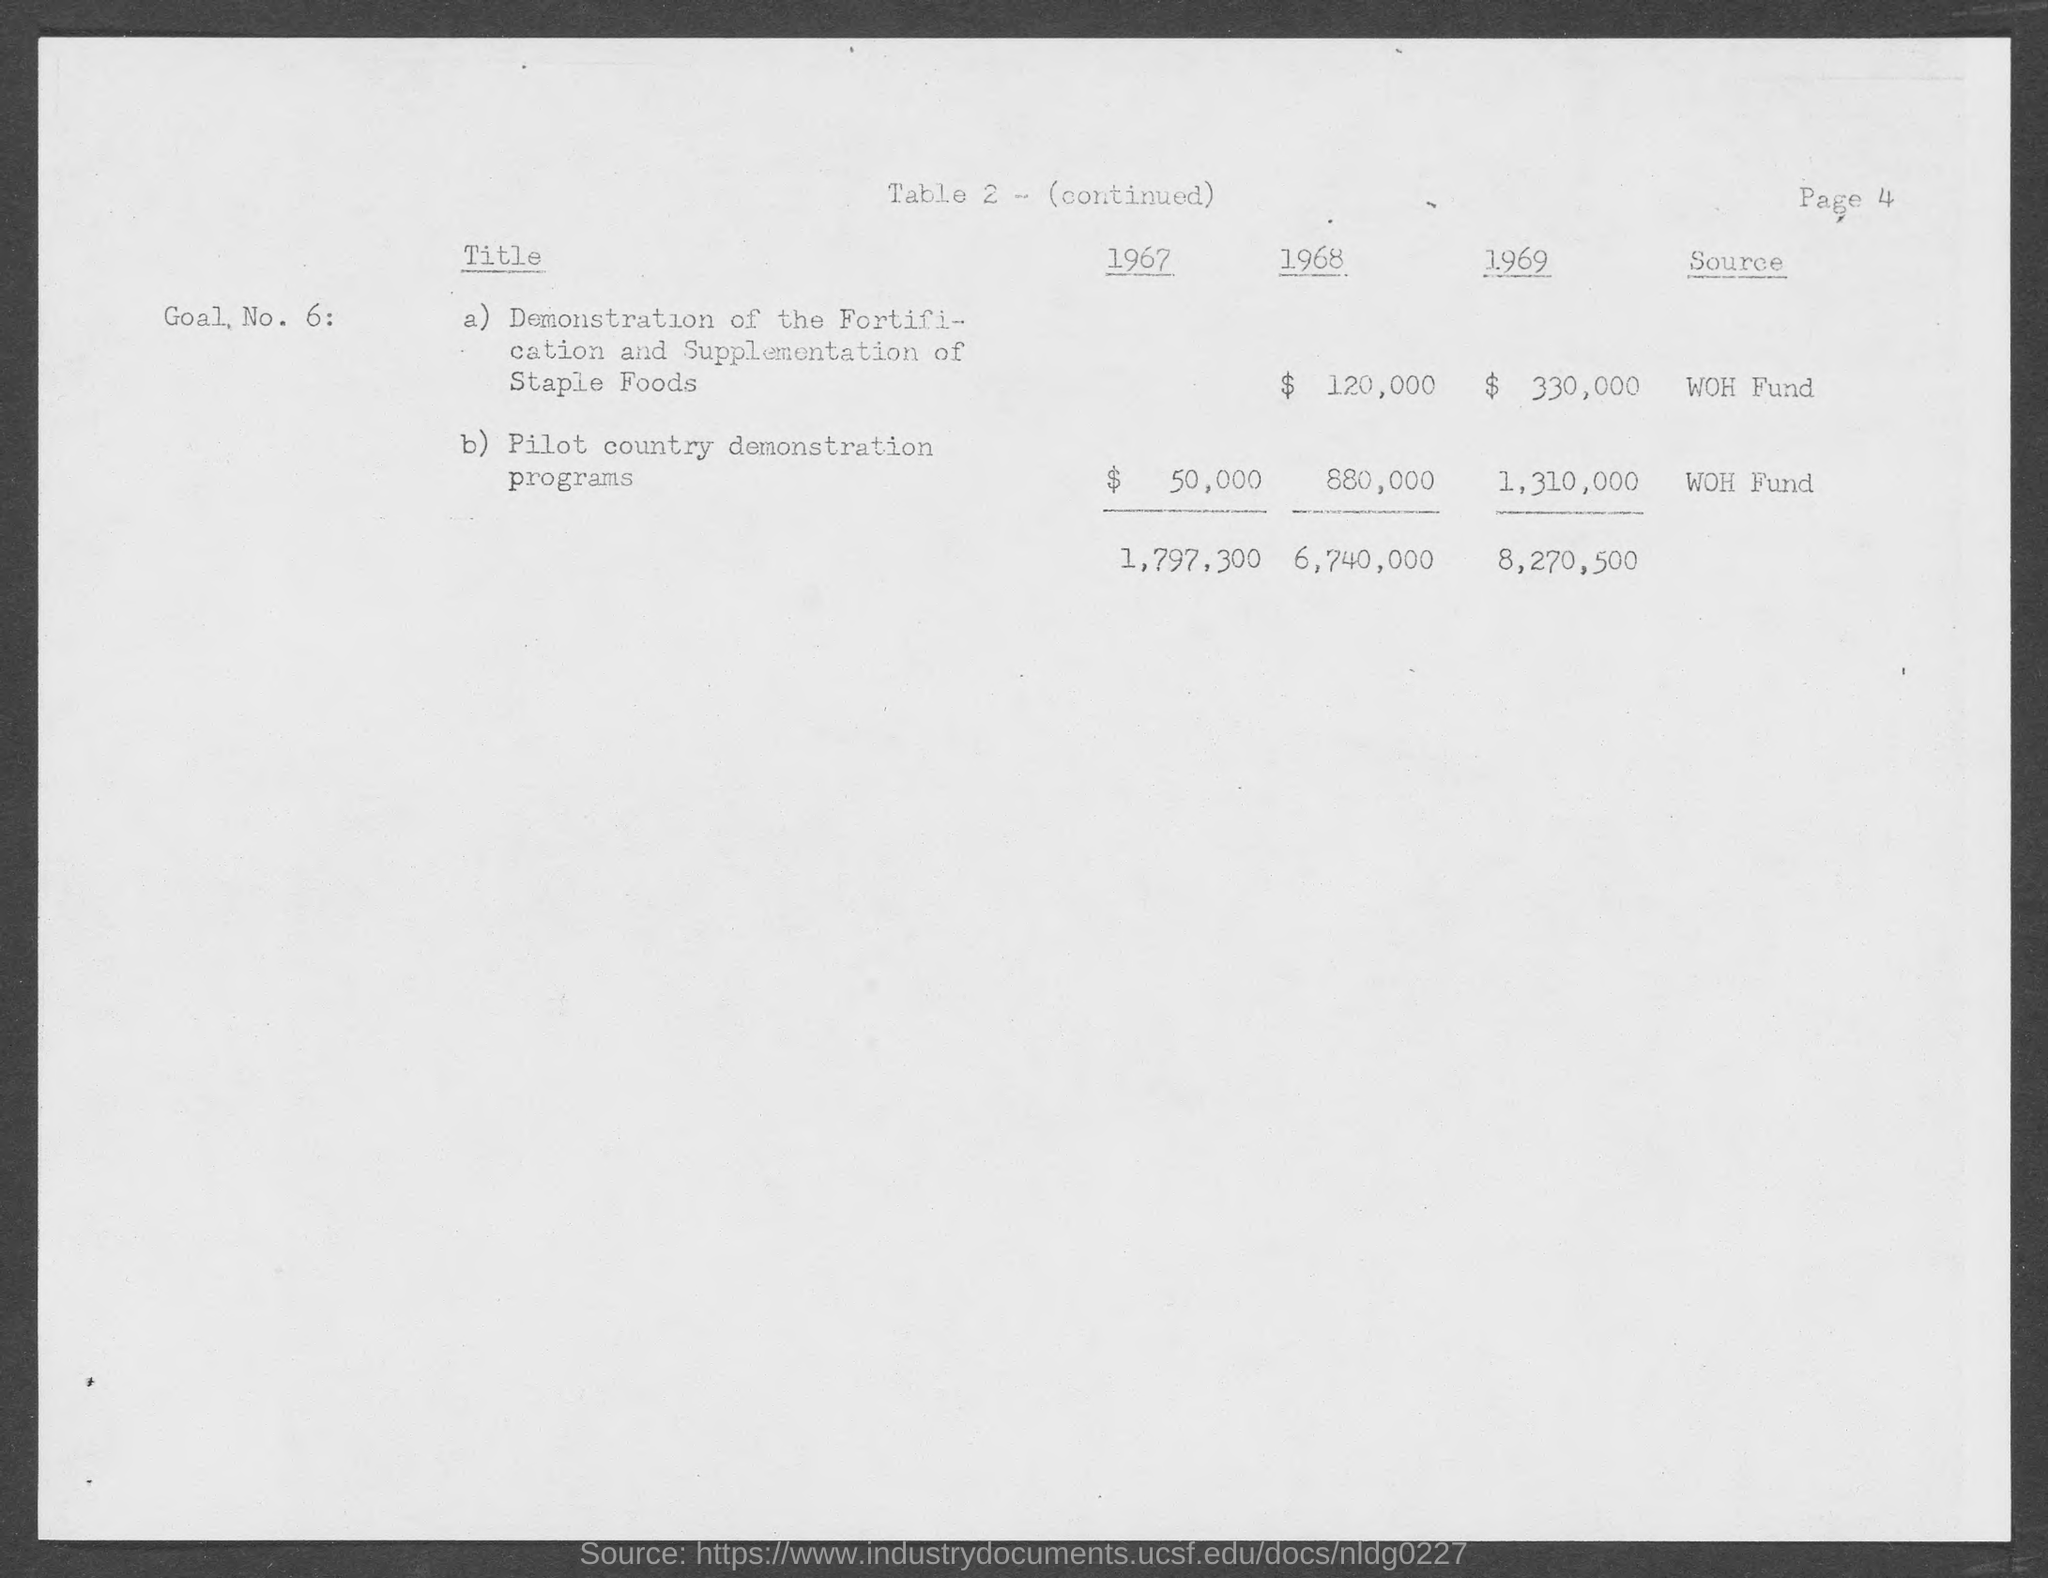What is the cost for Pilot country demonstration programs in the year 1967?
Provide a short and direct response. $50,000. What is the cost for demonstration of the Fortification and supplementation of staple foods in the year 1968?
Keep it short and to the point. $ 120,000. What is the page no mentioned in this document?
Offer a very short reply. PAGE 4. What is the source of fund for demonstration of the Fortification and supplementation of staple foods?
Offer a terse response. WOH Fund. What is the source of fund for Pilot country demonstration programs?
Make the answer very short. WOH FUND. 